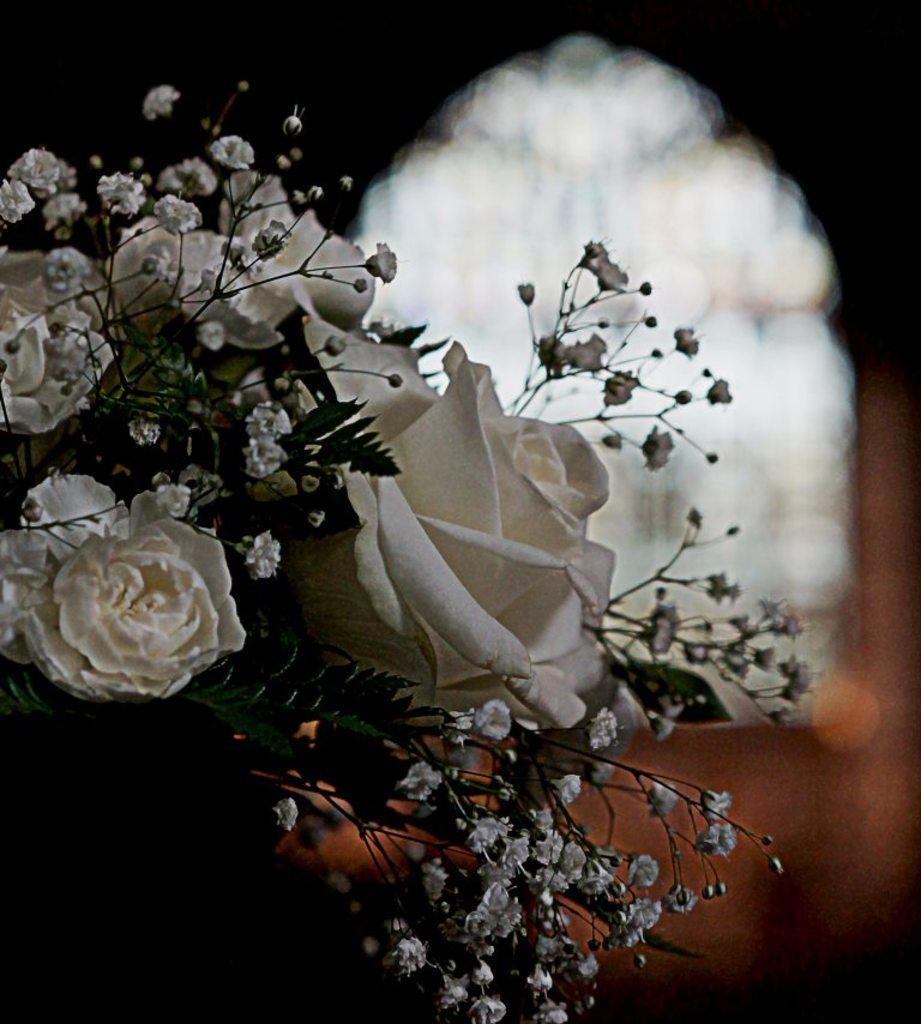What type of flora is present in the image? There are flowers in the image. What color are the flowers? The flowers are white in color. What other part of the plant can be seen in the image? There are green leaves in the image. How would you describe the background of the image? The background of the image is blurred. How many flags are visible in the image? There are no flags present in the image. What type of animal can be seen interacting with the flowers in the image? There are no animals, including chickens, present in the image. 